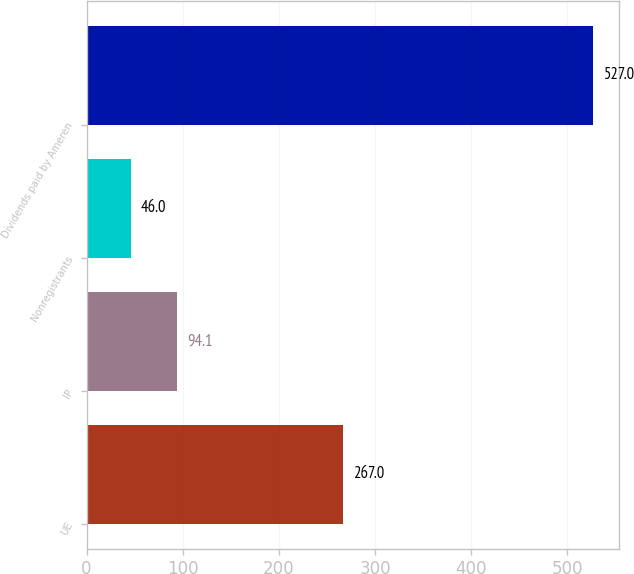Convert chart to OTSL. <chart><loc_0><loc_0><loc_500><loc_500><bar_chart><fcel>UE<fcel>IP<fcel>Nonregistrants<fcel>Dividends paid by Ameren<nl><fcel>267<fcel>94.1<fcel>46<fcel>527<nl></chart> 